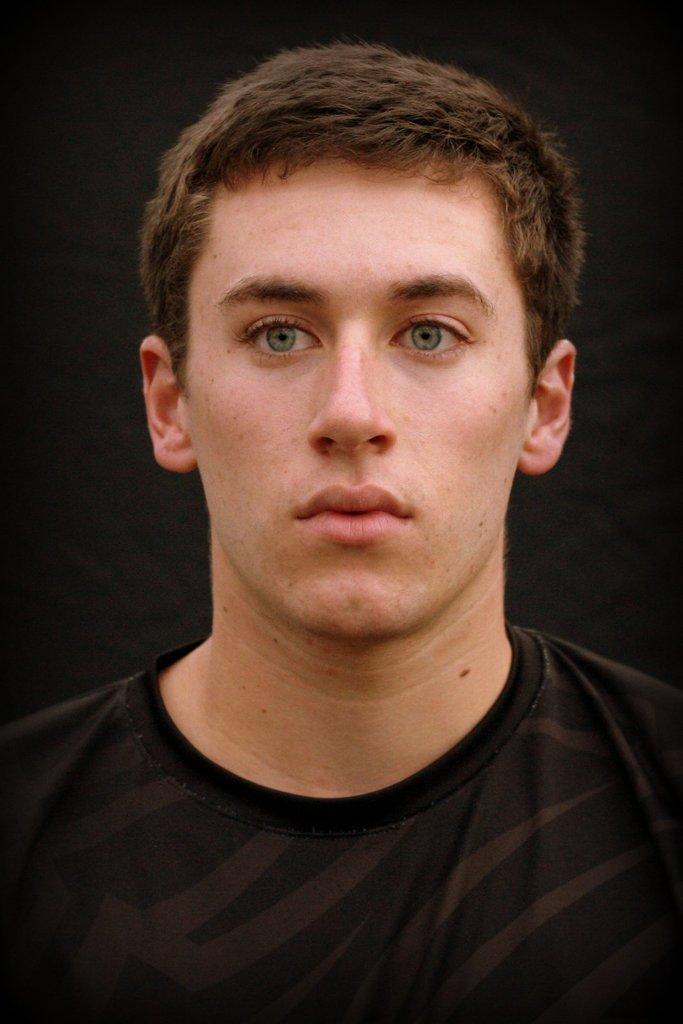Describe this image in one or two sentences. In this picture, we see the man is wearing a black color T-shirt. In the background, it is black in color. 